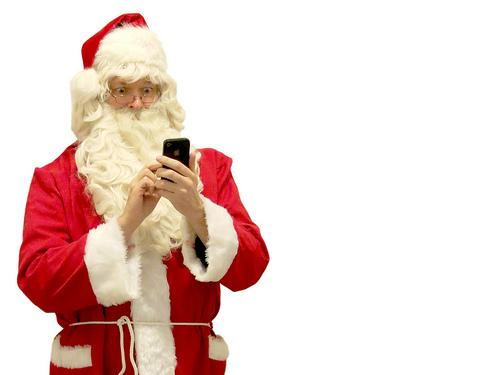Briefly explain what Santa Claus is holding in his hand and its color. Santa Claus is holding a black cell phone in his hand. Describe what the man is wearing on his face and head. The man is wearing a red Santa hat with white felt, a long white beard, and eyeglasses on his face. Identify the main subject of the image and what they are wearing. A man dressed as Santa Claus is wearing a red and white coat, hat, and long white beard, and is holding a black cellphone in his hand. In the visual entailment task, what would you infer about Santa in the picture? I would infer that Santa is using a cellphone, which is black, while dressed in his Christmas costume. For the multi-choice VQA task, choose the best description of the man's hat: a) Green and yellow b) Red and white c) Blue and gray b) Red and white In a referential expression grounding task, connect the described object to its description: "The object that helps Santa connect with his elves." The object that helps Santa connect with his elves is the black cellphone he is holding. Can you come up with a suitable slogan for a product advertisement based on the image? "Stay Connected This Christmas - Even Santa Loves His Smartphone!" What is the dominant color scheme of Santa Claus' outfit in the image? The dominant color scheme of Santa's outfit is red and white. Imagine you are explaining the image to someone who cannot see it. Describe the main subject and their appearance. The main subject in the image is a man dressed as Santa Claus, complete with a red and white coat, hat, eyeglasses, and a long white beard. He is holding a black cell phone in his hand. What is the common element found on Santa's coat and hat in the image? The common element found on Santa's coat and hat is white fur trim. 